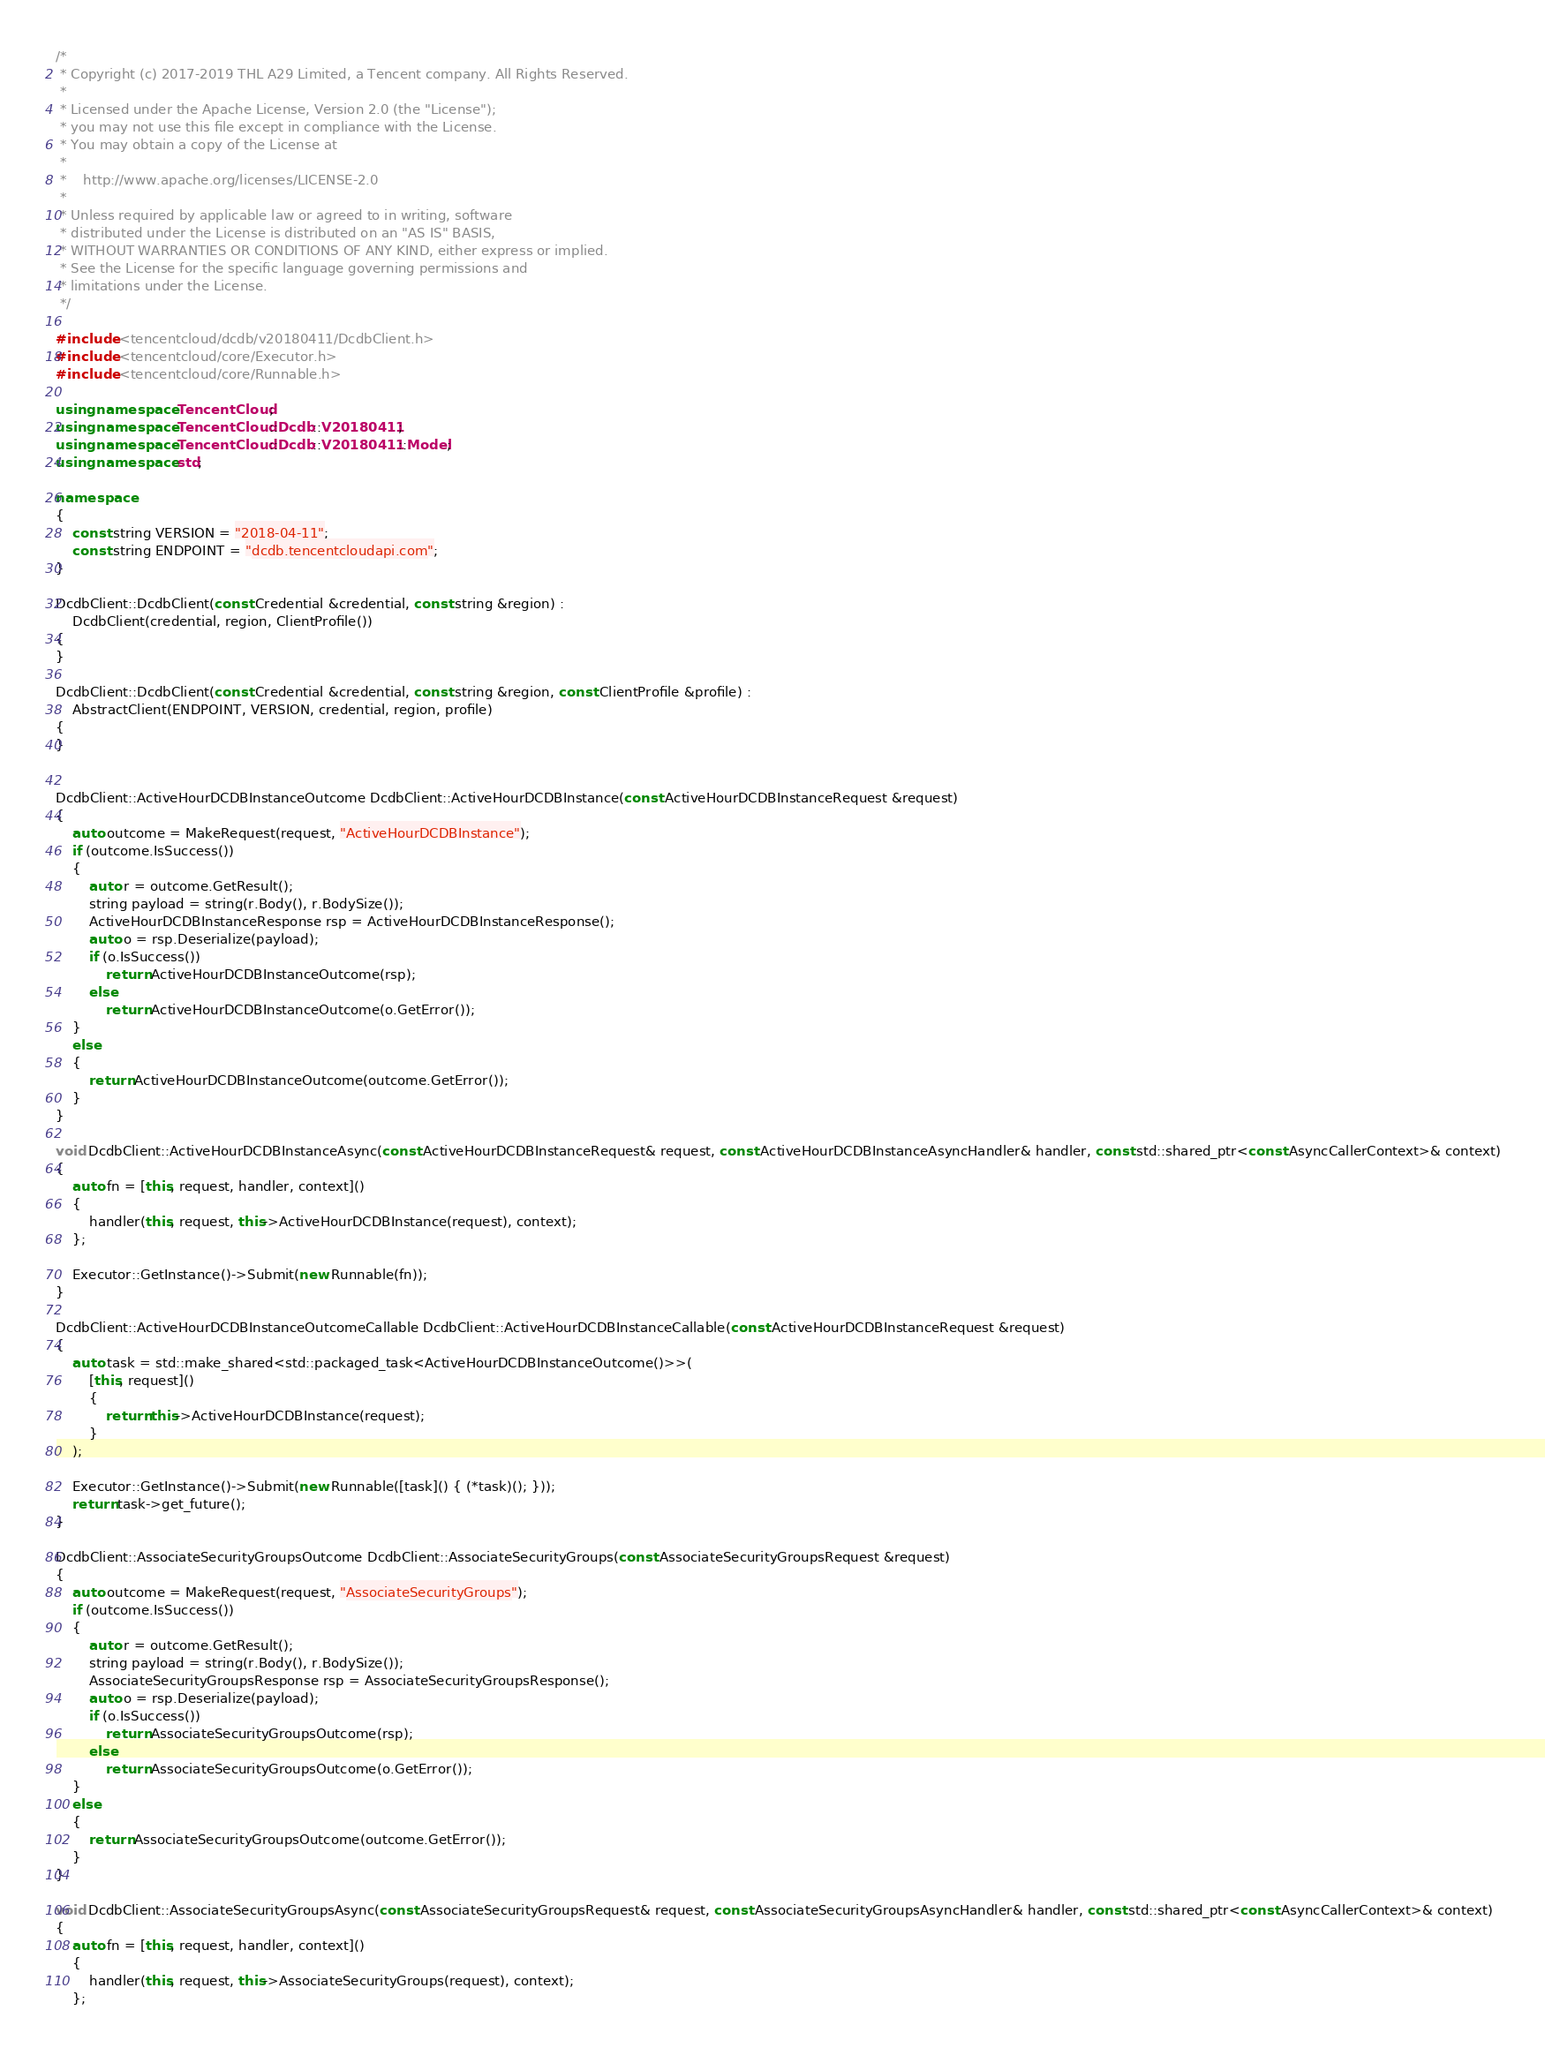Convert code to text. <code><loc_0><loc_0><loc_500><loc_500><_C++_>/*
 * Copyright (c) 2017-2019 THL A29 Limited, a Tencent company. All Rights Reserved.
 *
 * Licensed under the Apache License, Version 2.0 (the "License");
 * you may not use this file except in compliance with the License.
 * You may obtain a copy of the License at
 *
 *    http://www.apache.org/licenses/LICENSE-2.0
 *
 * Unless required by applicable law or agreed to in writing, software
 * distributed under the License is distributed on an "AS IS" BASIS,
 * WITHOUT WARRANTIES OR CONDITIONS OF ANY KIND, either express or implied.
 * See the License for the specific language governing permissions and
 * limitations under the License.
 */

#include <tencentcloud/dcdb/v20180411/DcdbClient.h>
#include <tencentcloud/core/Executor.h>
#include <tencentcloud/core/Runnable.h>

using namespace TencentCloud;
using namespace TencentCloud::Dcdb::V20180411;
using namespace TencentCloud::Dcdb::V20180411::Model;
using namespace std;

namespace
{
    const string VERSION = "2018-04-11";
    const string ENDPOINT = "dcdb.tencentcloudapi.com";
}

DcdbClient::DcdbClient(const Credential &credential, const string &region) :
    DcdbClient(credential, region, ClientProfile())
{
}

DcdbClient::DcdbClient(const Credential &credential, const string &region, const ClientProfile &profile) :
    AbstractClient(ENDPOINT, VERSION, credential, region, profile)
{
}


DcdbClient::ActiveHourDCDBInstanceOutcome DcdbClient::ActiveHourDCDBInstance(const ActiveHourDCDBInstanceRequest &request)
{
    auto outcome = MakeRequest(request, "ActiveHourDCDBInstance");
    if (outcome.IsSuccess())
    {
        auto r = outcome.GetResult();
        string payload = string(r.Body(), r.BodySize());
        ActiveHourDCDBInstanceResponse rsp = ActiveHourDCDBInstanceResponse();
        auto o = rsp.Deserialize(payload);
        if (o.IsSuccess())
            return ActiveHourDCDBInstanceOutcome(rsp);
        else
            return ActiveHourDCDBInstanceOutcome(o.GetError());
    }
    else
    {
        return ActiveHourDCDBInstanceOutcome(outcome.GetError());
    }
}

void DcdbClient::ActiveHourDCDBInstanceAsync(const ActiveHourDCDBInstanceRequest& request, const ActiveHourDCDBInstanceAsyncHandler& handler, const std::shared_ptr<const AsyncCallerContext>& context)
{
    auto fn = [this, request, handler, context]()
    {
        handler(this, request, this->ActiveHourDCDBInstance(request), context);
    };

    Executor::GetInstance()->Submit(new Runnable(fn));
}

DcdbClient::ActiveHourDCDBInstanceOutcomeCallable DcdbClient::ActiveHourDCDBInstanceCallable(const ActiveHourDCDBInstanceRequest &request)
{
    auto task = std::make_shared<std::packaged_task<ActiveHourDCDBInstanceOutcome()>>(
        [this, request]()
        {
            return this->ActiveHourDCDBInstance(request);
        }
    );

    Executor::GetInstance()->Submit(new Runnable([task]() { (*task)(); }));
    return task->get_future();
}

DcdbClient::AssociateSecurityGroupsOutcome DcdbClient::AssociateSecurityGroups(const AssociateSecurityGroupsRequest &request)
{
    auto outcome = MakeRequest(request, "AssociateSecurityGroups");
    if (outcome.IsSuccess())
    {
        auto r = outcome.GetResult();
        string payload = string(r.Body(), r.BodySize());
        AssociateSecurityGroupsResponse rsp = AssociateSecurityGroupsResponse();
        auto o = rsp.Deserialize(payload);
        if (o.IsSuccess())
            return AssociateSecurityGroupsOutcome(rsp);
        else
            return AssociateSecurityGroupsOutcome(o.GetError());
    }
    else
    {
        return AssociateSecurityGroupsOutcome(outcome.GetError());
    }
}

void DcdbClient::AssociateSecurityGroupsAsync(const AssociateSecurityGroupsRequest& request, const AssociateSecurityGroupsAsyncHandler& handler, const std::shared_ptr<const AsyncCallerContext>& context)
{
    auto fn = [this, request, handler, context]()
    {
        handler(this, request, this->AssociateSecurityGroups(request), context);
    };
</code> 